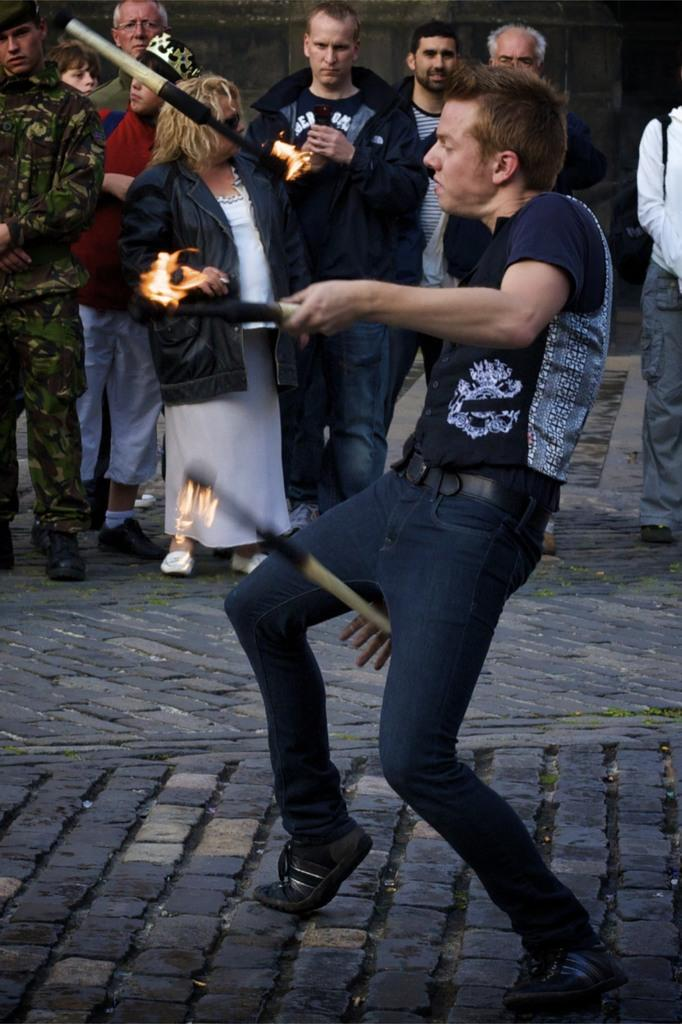What is the man in the image doing? The man is playing with fire in the image. How is the fire arranged in the image? The fire is on sticks on the ground. Can you describe the people in the background of the image? There are persons standing in the background of the image. What can be seen in the background of the image besides the people? There is a wall visible in the background of the image. How many jellyfish are swimming in the fire in the image? There are no jellyfish present in the image, and the fire is on sticks on the ground, not in water. 